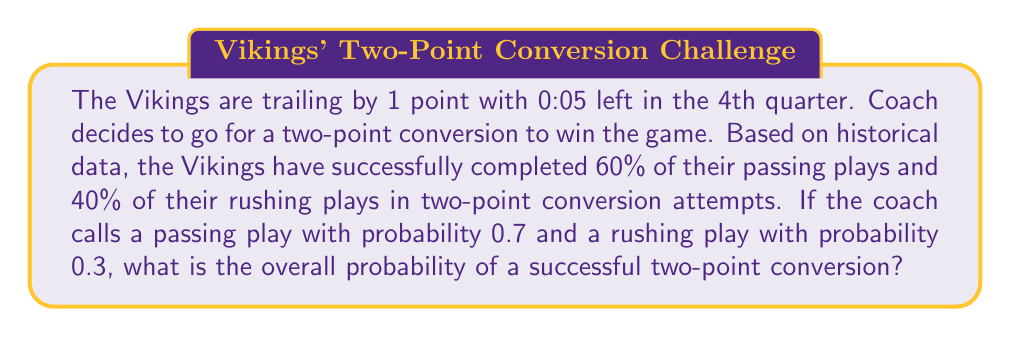Solve this math problem. Let's approach this step-by-step:

1) Define events:
   P = Passing play is called
   R = Rushing play is called
   S = Successful two-point conversion

2) Given probabilities:
   $P(P) = 0.7$
   $P(R) = 0.3$
   $P(S|P) = 0.6$ (probability of success given a passing play)
   $P(S|R) = 0.4$ (probability of success given a rushing play)

3) We can use the law of total probability:
   $$P(S) = P(S|P) \cdot P(P) + P(S|R) \cdot P(R)$$

4) Substitute the values:
   $$P(S) = 0.6 \cdot 0.7 + 0.4 \cdot 0.3$$

5) Calculate:
   $$P(S) = 0.42 + 0.12 = 0.54$$

Therefore, the overall probability of a successful two-point conversion is 0.54 or 54%.
Answer: 0.54 